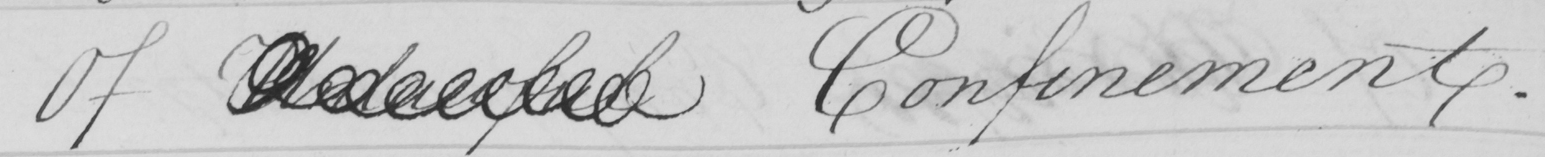Transcribe the text shown in this historical manuscript line. Of Unlawful Confinement . 